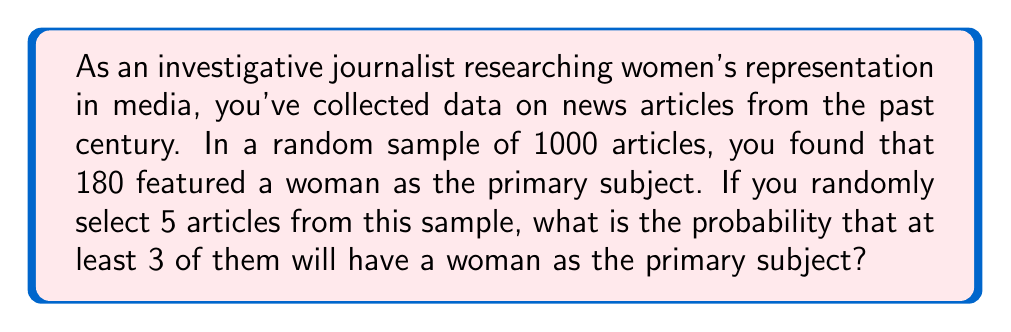Provide a solution to this math problem. To solve this problem, we'll use the binomial probability distribution.

1. Let's define our variables:
   $n = 5$ (number of articles selected)
   $p = 180/1000 = 0.18$ (probability of an article featuring a woman as the primary subject)
   $q = 1 - p = 0.82$ (probability of an article not featuring a woman as the primary subject)

2. We need to calculate the probability of at least 3 articles featuring a woman. This means we need to sum the probabilities of exactly 3, 4, and 5 articles featuring a woman.

3. The binomial probability formula is:
   $$P(X = k) = \binom{n}{k} p^k q^{n-k}$$

4. Let's calculate each probability:

   For 3 articles: $P(X = 3) = \binom{5}{3} (0.18)^3 (0.82)^2$
   For 4 articles: $P(X = 4) = \binom{5}{4} (0.18)^4 (0.82)^1$
   For 5 articles: $P(X = 5) = \binom{5}{5} (0.18)^5 (0.82)^0$

5. Calculating each probability:
   $P(X = 3) = 10 \times 0.005832 \times 0.6724 = 0.03924$
   $P(X = 4) = 5 \times 0.001049 \times 0.82 = 0.004301$
   $P(X = 5) = 1 \times 0.0001889 \times 1 = 0.0001889$

6. Sum these probabilities:
   $P(X \geq 3) = 0.03924 + 0.004301 + 0.0001889 = 0.04373$

Therefore, the probability of at least 3 out of 5 randomly selected articles featuring a woman as the primary subject is approximately 0.04373 or 4.373%.
Answer: 0.04373 or 4.373% 